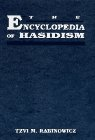What type of book is this? This is a book on Religion & Spirituality, specifically focusing on Hasidic Judaism. It serves as an educational text that provides a comprehensive overview of Hasidic beliefs, traditions, and community life. 